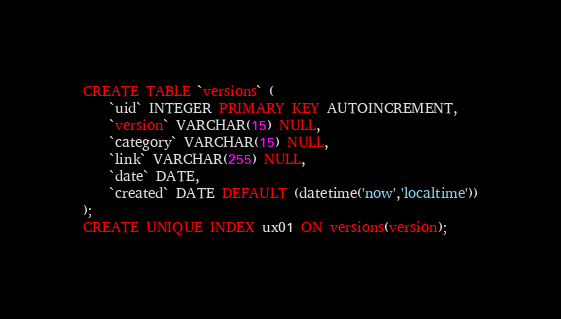<code> <loc_0><loc_0><loc_500><loc_500><_SQL_>CREATE TABLE `versions` (
    `uid` INTEGER PRIMARY KEY AUTOINCREMENT,
    `version` VARCHAR(15) NULL,
    `category` VARCHAR(15) NULL,
    `link` VARCHAR(255) NULL,
    `date` DATE,
    `created` DATE DEFAULT (datetime('now','localtime'))
);
CREATE UNIQUE INDEX ux01 ON versions(version);
</code> 